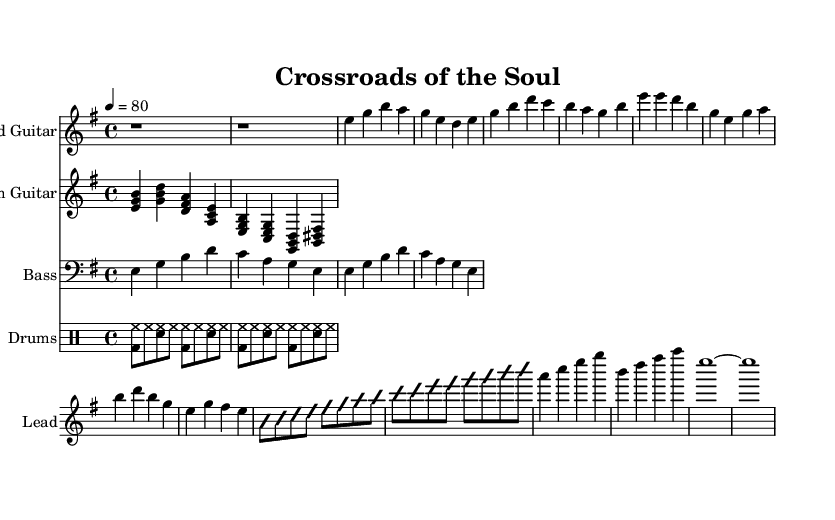What is the key signature of this music? The key signature is E minor, which has one sharp (F#).
Answer: E minor What is the time signature of this music? The time signature is 4/4, indicating four beats per measure.
Answer: 4/4 What is the tempo marking in this piece? The tempo marking is indicated as 80 beats per minute.
Answer: 80 Which instruments are featured in this piece? The piece features lead guitar, rhythm guitar, bass, and drums.
Answer: Lead guitar, rhythm guitar, bass, drums What type of musical scale is primarily used in the guitar solo? The guitar solo showcases a major scale, as it moves through sequential notes like b, c, d, e.
Answer: Major scale How does the rhythm guitar contribute to the overall sound? The rhythm guitar plays chords that support the harmonic structure during verses and choruses, enhancing the musical texture.
Answer: Supports harmony What motif is explored throughout the song's structure? The song explores themes of inner turmoil and the struggle between good and evil, represented musically through contrasting sections.
Answer: Inner turmoil 